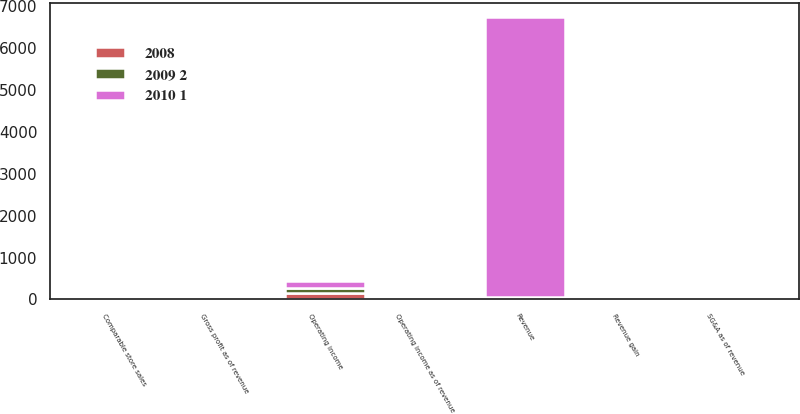Convert chart. <chart><loc_0><loc_0><loc_500><loc_500><stacked_bar_chart><ecel><fcel>Revenue<fcel>Revenue gain<fcel>Comparable store sales<fcel>Gross profit as of revenue<fcel>SG&A as of revenue<fcel>Operating income<fcel>Operating income as of revenue<nl><fcel>2008<fcel>23.8<fcel>24.5<fcel>3.7<fcel>25.3<fcel>23.8<fcel>164<fcel>1.3<nl><fcel>2009 2<fcel>23.8<fcel>48.6<fcel>0.9<fcel>23.9<fcel>22.7<fcel>112<fcel>1.1<nl><fcel>2010 1<fcel>6695<fcel>36.5<fcel>9<fcel>20.7<fcel>18.3<fcel>162<fcel>2.4<nl></chart> 